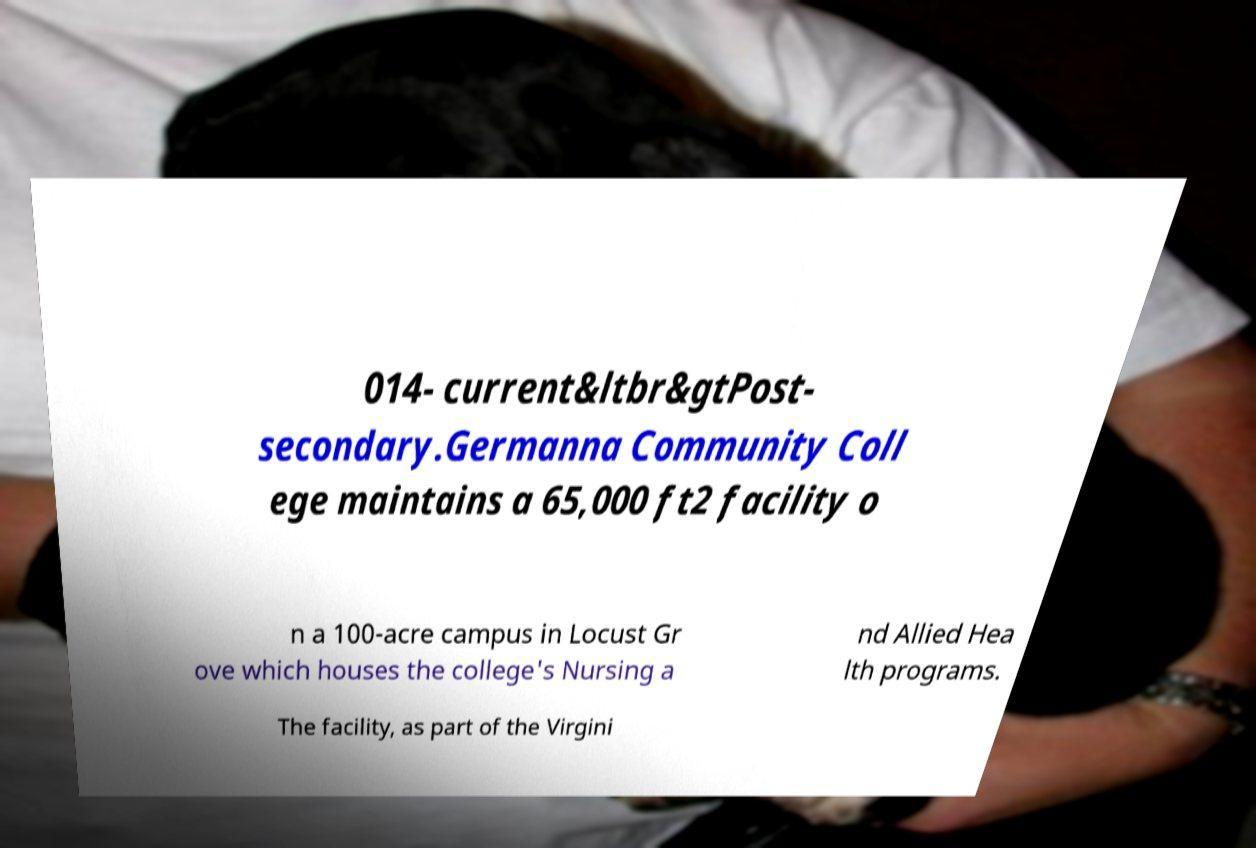For documentation purposes, I need the text within this image transcribed. Could you provide that? 014- current&ltbr&gtPost- secondary.Germanna Community Coll ege maintains a 65,000 ft2 facility o n a 100-acre campus in Locust Gr ove which houses the college's Nursing a nd Allied Hea lth programs. The facility, as part of the Virgini 